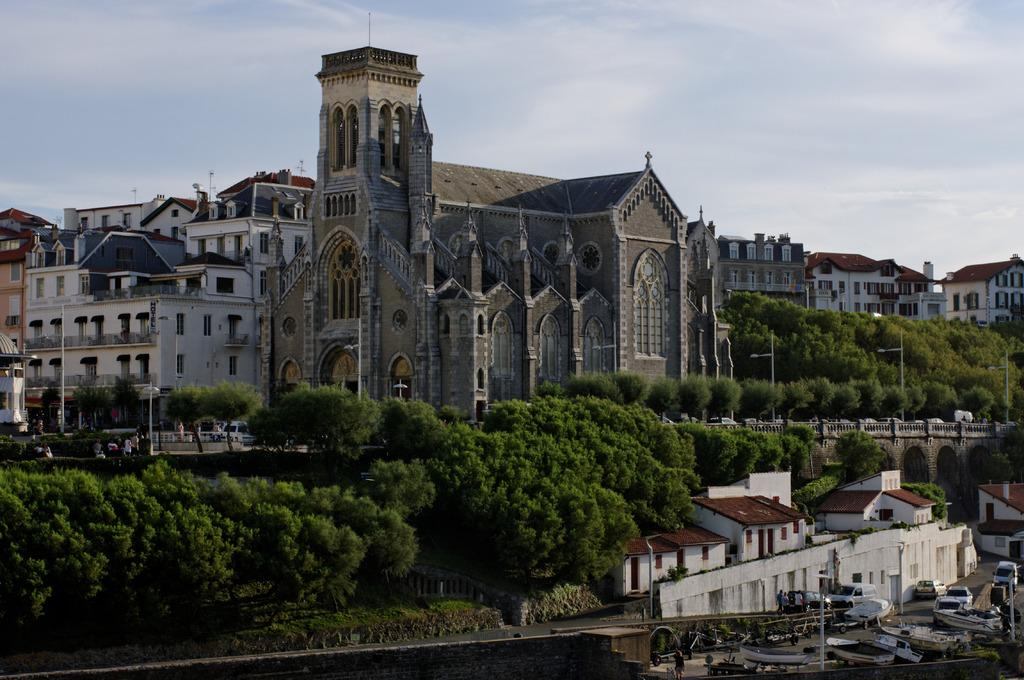What can be seen moving on the road in the image? There are vehicles on the road in the image. What type of natural scenery is visible in the background? There are trees in the background of the image. What is the color of the trees in the image? The trees are green in color. What type of man-made structures are visible in the background? There are buildings in the background of the image. What part of the natural environment is visible in the image? A: The sky is visible in the image. What colors can be seen in the sky in the image? The sky has white and blue colors. Where is the book located in the image? There is no book present in the image. Can you describe the person walking on the road in the image? There is no person walking on the road in the image. 